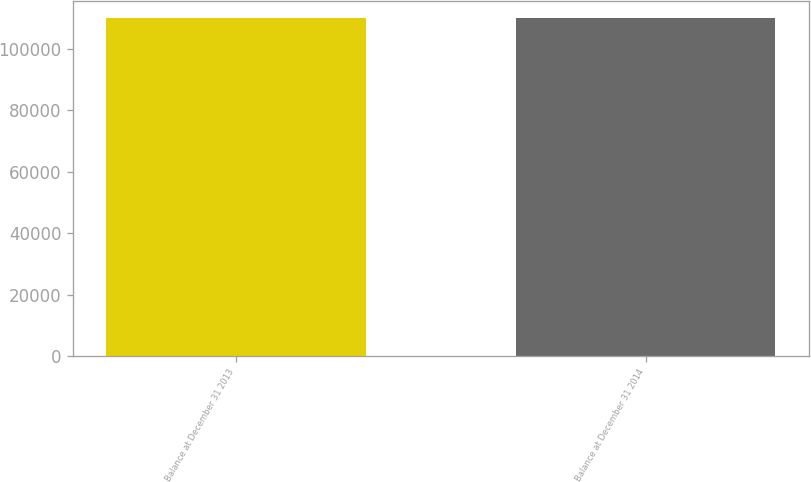<chart> <loc_0><loc_0><loc_500><loc_500><bar_chart><fcel>Balance at December 31 2013<fcel>Balance at December 31 2014<nl><fcel>110000<fcel>110000<nl></chart> 